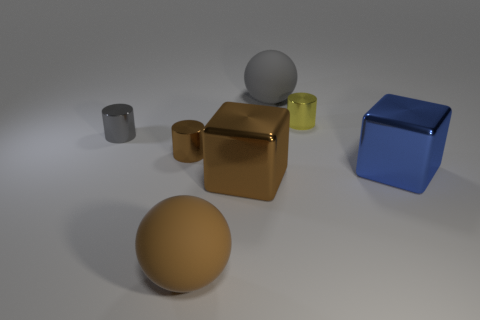Add 2 small blue metal things. How many objects exist? 9 Subtract all spheres. How many objects are left? 5 Subtract all purple balls. Subtract all big blocks. How many objects are left? 5 Add 7 large gray spheres. How many large gray spheres are left? 8 Add 1 large objects. How many large objects exist? 5 Subtract 0 purple balls. How many objects are left? 7 